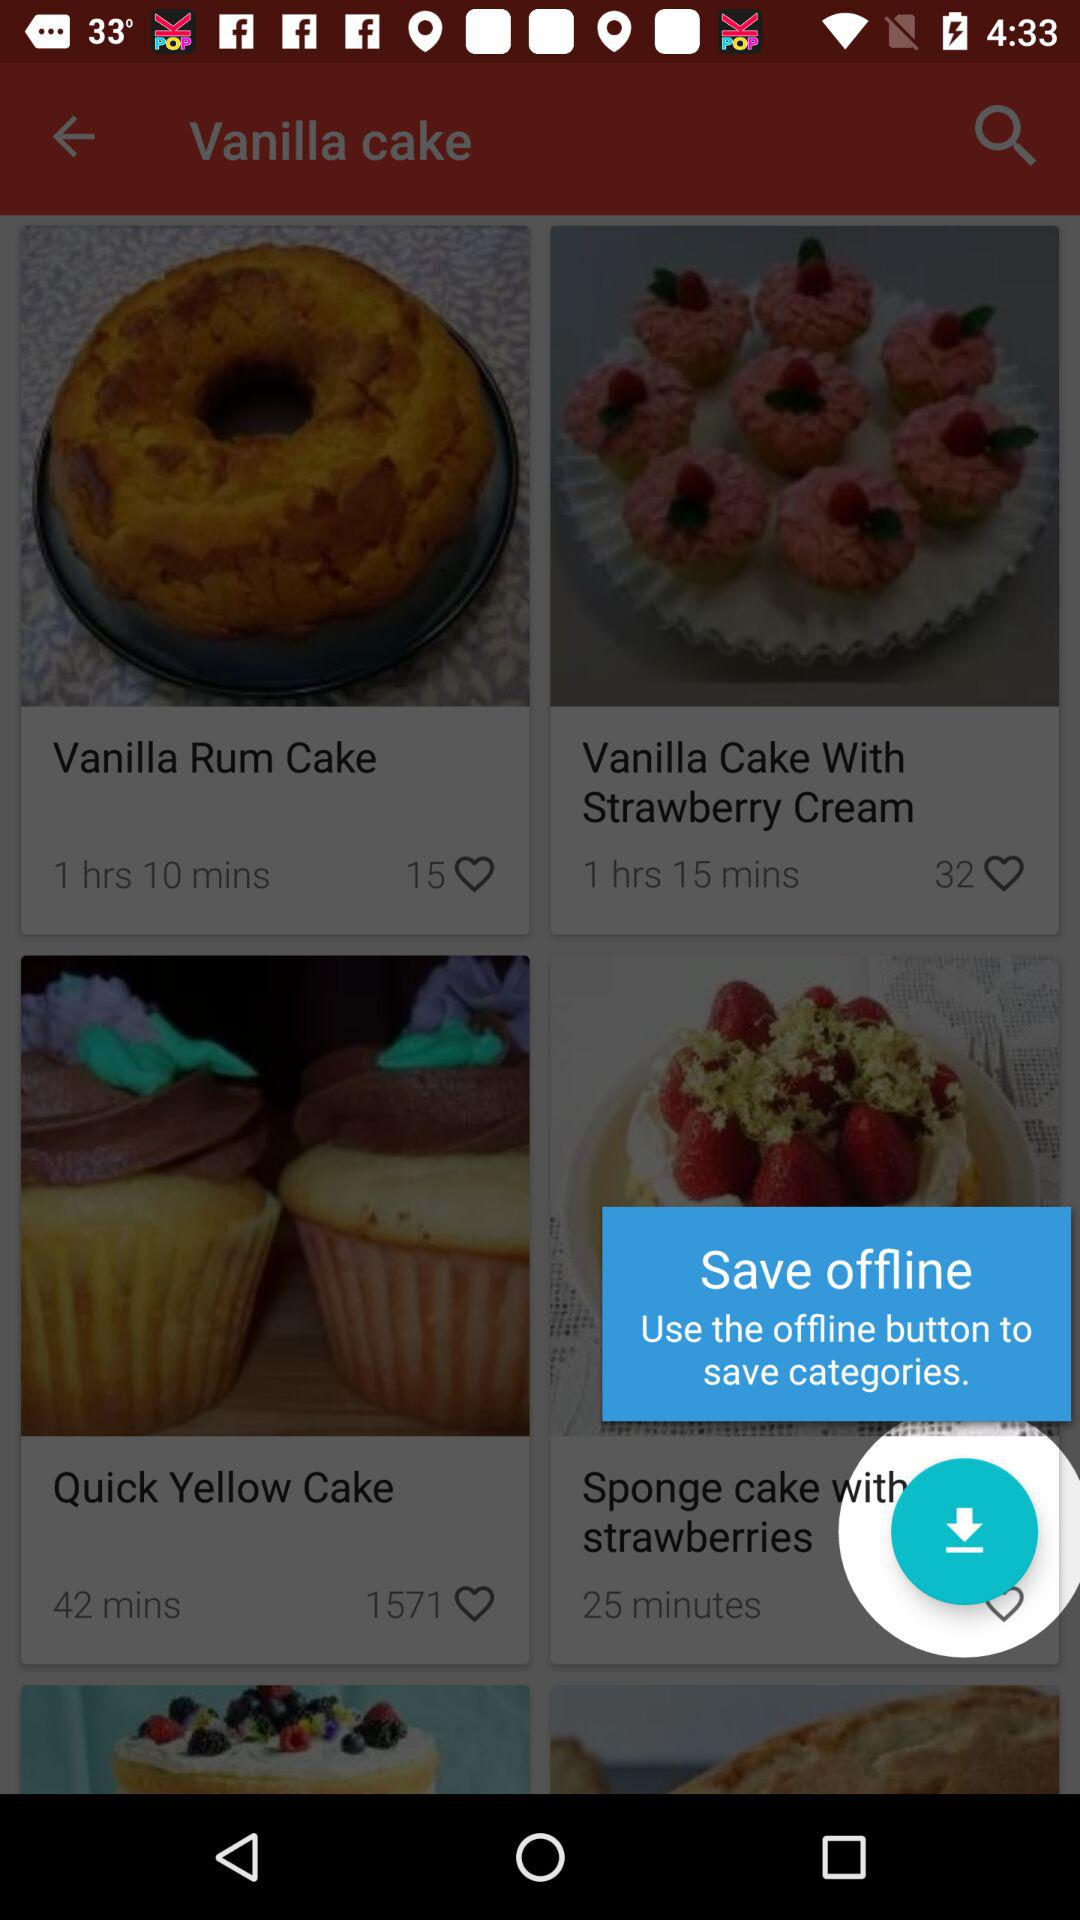In how much time is "Vanilla Rum Cake" prepared? "Vanilla Rum Cake" is prepared in 1 hour 10 minutes. 